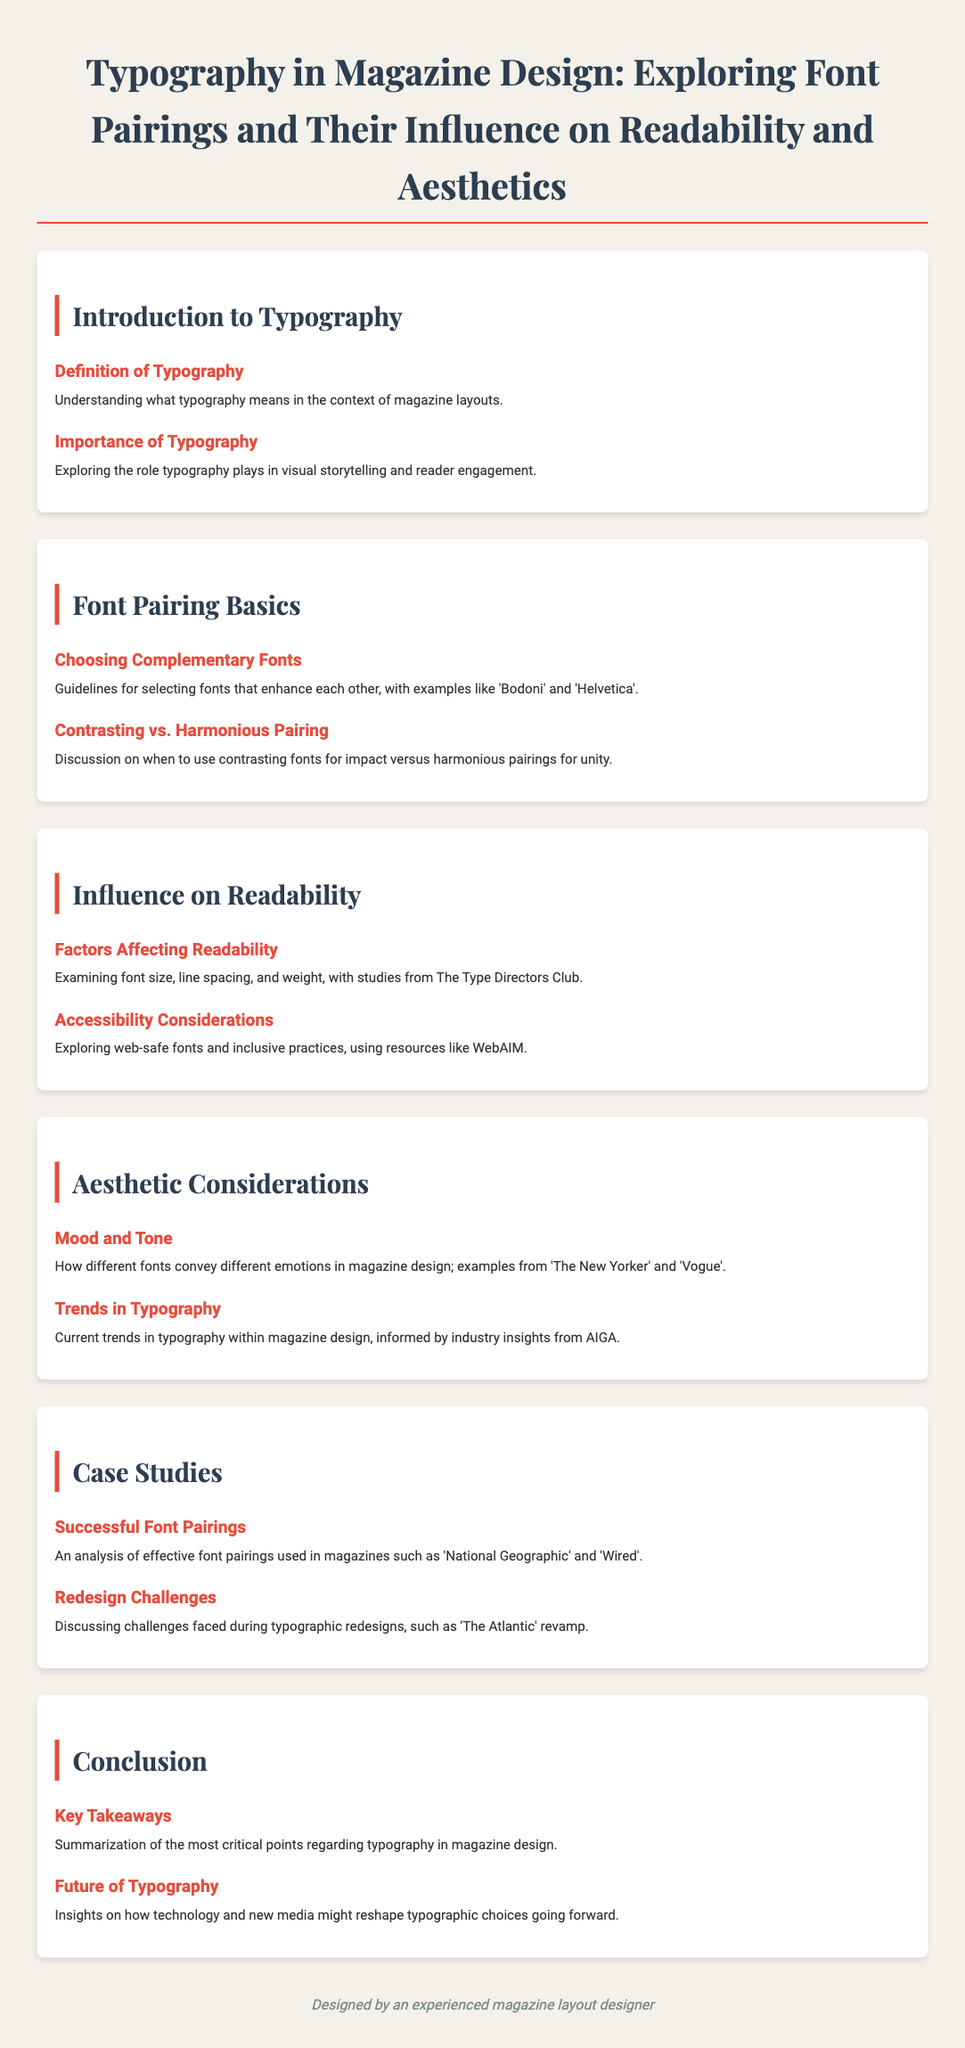What is the title of the document? The title is found in the header of the document, which states the main topic of discussion.
Answer: Typography in Magazine Design: Exploring Font Pairings and Their Influence on Readability and Aesthetic How many sections are there in the agenda? The document lists distinct sections that group related topics; counting them reveals the total number of sections.
Answer: 6 What font is used for headings? The document specifies the font family applied to headings, distinguishing them from body text.
Answer: Playfair Display What is the first agenda item under the introduction section? By reviewing the agenda section titles, we can determine the first specific topic listed for discussion.
Answer: Definition of Typography What is discussed in the "Mood and Tone" agenda item? This item explores how various fonts are utilized to convey different emotions in the context of magazine design.
Answer: Fonts convey different emotions What magazine was analyzed for successful font pairings? Insights from design practices are drawn from specific magazines mentioned within the case studies section.
Answer: National Geographic What is highlighted in the "Future of Typography" discussion? This item focuses on the evolving impacts of technology and new media on typography choices.
Answer: Technology and new media What color is used for the section headings? The document specifies a particular color for headings to create visual distinction and hierarchy.
Answer: #2c3e50 